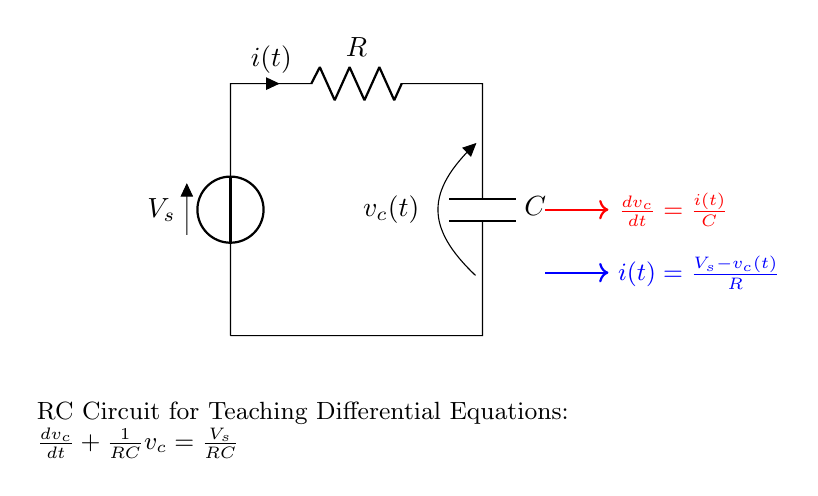What is the value of the resistor in this circuit? The circuit diagram indicates that the resistor is labeled as R. Therefore, its specific value would need to be provided separately.
Answer: R What is the maximum voltage seen by the capacitor? The circuit's voltage source V_s defines the maximum voltage that the capacitor can reach once fully charged. This is the input voltage that the circuit operates with.
Answer: V_s What is the equation that describes the change in capacitor voltage over time? The diagram shows an arrow and note indicating the change in voltage across the capacitor is expressed as dv_c/dt = i(t)/C. This describes how the voltage changes with respect to time.
Answer: dv_c/dt = i(t)/C What circuit components are involved in this RC circuit? The diagram clearly displays two components: a resistor and a capacitor in series with a voltage source. Identifying these components is essential to understanding the circuit's function.
Answer: Resistor and Capacitor What is the relationship between current and voltage across the resistor? The diagram includes an equation stating that the current i(t) is equal to (V_s - v_c(t))/R, which relates the current flowing through the circuit to the voltage drop across the resistor and the voltage across the capacitor.
Answer: i(t) = (V_s - v_c(t))/R What is the differential equation governing this RC circuit? The circuit is associated with the differential equation dv_c/dt + (1/RC)v_c = V_s/(RC), representing the dynamic behavior of the capacitor voltage in response to the circuit parameters.
Answer: dv_c/dt + (1/RC)v_c = V_s/(RC) What happens to the voltage across the capacitor as time progresses? As time increases, the voltage across the capacitor approaches V_s, indicating that the capacitor charges up towards the maximum potential defined by V_s over time until it reaches a steady state.
Answer: Approaches V_s 